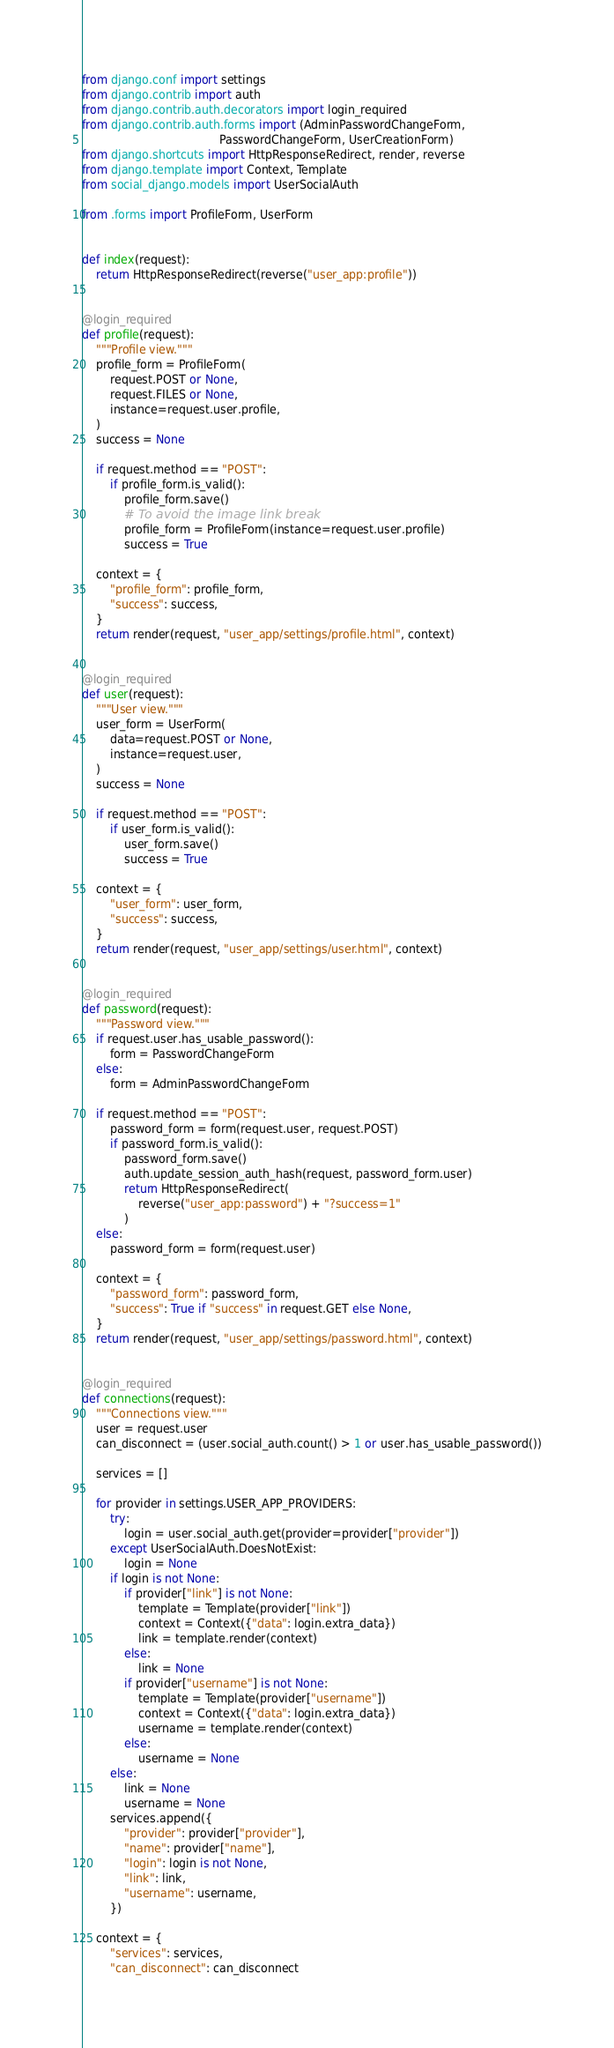Convert code to text. <code><loc_0><loc_0><loc_500><loc_500><_Python_>from django.conf import settings
from django.contrib import auth
from django.contrib.auth.decorators import login_required
from django.contrib.auth.forms import (AdminPasswordChangeForm,
                                       PasswordChangeForm, UserCreationForm)
from django.shortcuts import HttpResponseRedirect, render, reverse
from django.template import Context, Template
from social_django.models import UserSocialAuth

from .forms import ProfileForm, UserForm


def index(request):
    return HttpResponseRedirect(reverse("user_app:profile"))


@login_required
def profile(request):
    """Profile view."""
    profile_form = ProfileForm(
        request.POST or None,
        request.FILES or None,
        instance=request.user.profile,
    )
    success = None

    if request.method == "POST":
        if profile_form.is_valid():
            profile_form.save()
            # To avoid the image link break
            profile_form = ProfileForm(instance=request.user.profile)
            success = True

    context = {
        "profile_form": profile_form,
        "success": success,
    }
    return render(request, "user_app/settings/profile.html", context)


@login_required
def user(request):
    """User view."""
    user_form = UserForm(
        data=request.POST or None,
        instance=request.user,
    )
    success = None

    if request.method == "POST":
        if user_form.is_valid():
            user_form.save()
            success = True

    context = {
        "user_form": user_form,
        "success": success,
    }
    return render(request, "user_app/settings/user.html", context)


@login_required
def password(request):
    """Password view."""
    if request.user.has_usable_password():
        form = PasswordChangeForm
    else:
        form = AdminPasswordChangeForm

    if request.method == "POST":
        password_form = form(request.user, request.POST)
        if password_form.is_valid():
            password_form.save()
            auth.update_session_auth_hash(request, password_form.user)
            return HttpResponseRedirect(
                reverse("user_app:password") + "?success=1"
            )
    else:
        password_form = form(request.user)

    context = {
        "password_form": password_form,
        "success": True if "success" in request.GET else None,
    }
    return render(request, "user_app/settings/password.html", context)


@login_required
def connections(request):
    """Connections view."""
    user = request.user
    can_disconnect = (user.social_auth.count() > 1 or user.has_usable_password())

    services = []

    for provider in settings.USER_APP_PROVIDERS:
        try:
            login = user.social_auth.get(provider=provider["provider"])
        except UserSocialAuth.DoesNotExist:
            login = None
        if login is not None:
            if provider["link"] is not None:
                template = Template(provider["link"])
                context = Context({"data": login.extra_data})
                link = template.render(context)
            else:
                link = None
            if provider["username"] is not None:
                template = Template(provider["username"])
                context = Context({"data": login.extra_data})
                username = template.render(context)
            else:
                username = None
        else:
            link = None
            username = None
        services.append({
            "provider": provider["provider"],
            "name": provider["name"],
            "login": login is not None,
            "link": link,
            "username": username,
        })

    context = {
        "services": services,
        "can_disconnect": can_disconnect</code> 